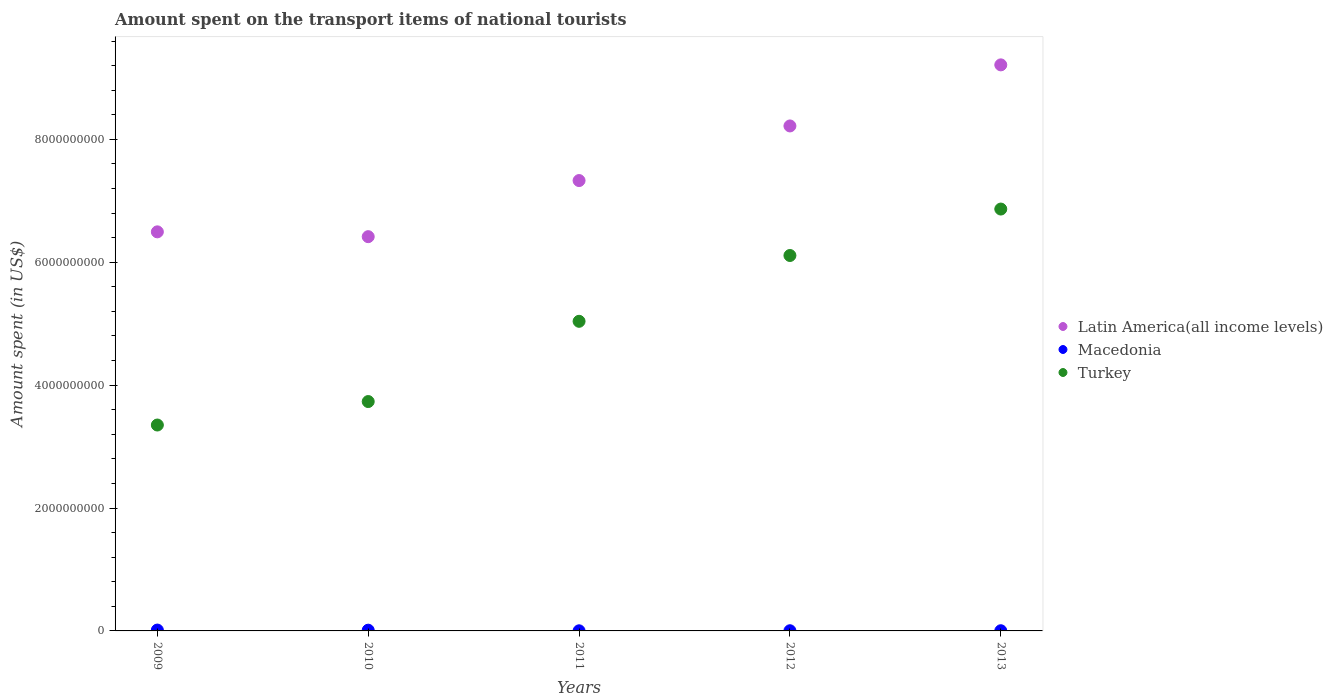What is the amount spent on the transport items of national tourists in Turkey in 2013?
Provide a short and direct response. 6.87e+09. Across all years, what is the maximum amount spent on the transport items of national tourists in Latin America(all income levels)?
Keep it short and to the point. 9.21e+09. Across all years, what is the minimum amount spent on the transport items of national tourists in Latin America(all income levels)?
Keep it short and to the point. 6.42e+09. In which year was the amount spent on the transport items of national tourists in Latin America(all income levels) maximum?
Offer a terse response. 2013. What is the total amount spent on the transport items of national tourists in Macedonia in the graph?
Your answer should be compact. 3.40e+07. What is the difference between the amount spent on the transport items of national tourists in Latin America(all income levels) in 2009 and that in 2011?
Your answer should be compact. -8.35e+08. What is the difference between the amount spent on the transport items of national tourists in Turkey in 2009 and the amount spent on the transport items of national tourists in Macedonia in 2010?
Provide a succinct answer. 3.34e+09. What is the average amount spent on the transport items of national tourists in Macedonia per year?
Provide a short and direct response. 6.80e+06. In the year 2013, what is the difference between the amount spent on the transport items of national tourists in Latin America(all income levels) and amount spent on the transport items of national tourists in Turkey?
Your answer should be very brief. 2.35e+09. What is the ratio of the amount spent on the transport items of national tourists in Turkey in 2012 to that in 2013?
Your answer should be compact. 0.89. What is the difference between the highest and the second highest amount spent on the transport items of national tourists in Macedonia?
Offer a very short reply. 2.00e+06. What is the difference between the highest and the lowest amount spent on the transport items of national tourists in Latin America(all income levels)?
Your answer should be compact. 2.80e+09. Is the amount spent on the transport items of national tourists in Turkey strictly less than the amount spent on the transport items of national tourists in Latin America(all income levels) over the years?
Make the answer very short. Yes. How many years are there in the graph?
Your response must be concise. 5. Does the graph contain any zero values?
Your answer should be very brief. No. Where does the legend appear in the graph?
Make the answer very short. Center right. How are the legend labels stacked?
Ensure brevity in your answer.  Vertical. What is the title of the graph?
Offer a very short reply. Amount spent on the transport items of national tourists. What is the label or title of the Y-axis?
Ensure brevity in your answer.  Amount spent (in US$). What is the Amount spent (in US$) in Latin America(all income levels) in 2009?
Your answer should be very brief. 6.49e+09. What is the Amount spent (in US$) in Macedonia in 2009?
Your response must be concise. 1.40e+07. What is the Amount spent (in US$) in Turkey in 2009?
Offer a very short reply. 3.35e+09. What is the Amount spent (in US$) of Latin America(all income levels) in 2010?
Keep it short and to the point. 6.42e+09. What is the Amount spent (in US$) of Macedonia in 2010?
Provide a short and direct response. 1.20e+07. What is the Amount spent (in US$) of Turkey in 2010?
Provide a succinct answer. 3.73e+09. What is the Amount spent (in US$) of Latin America(all income levels) in 2011?
Offer a very short reply. 7.33e+09. What is the Amount spent (in US$) in Turkey in 2011?
Your response must be concise. 5.04e+09. What is the Amount spent (in US$) of Latin America(all income levels) in 2012?
Offer a very short reply. 8.22e+09. What is the Amount spent (in US$) in Turkey in 2012?
Make the answer very short. 6.11e+09. What is the Amount spent (in US$) of Latin America(all income levels) in 2013?
Your answer should be compact. 9.21e+09. What is the Amount spent (in US$) of Turkey in 2013?
Offer a terse response. 6.87e+09. Across all years, what is the maximum Amount spent (in US$) of Latin America(all income levels)?
Offer a terse response. 9.21e+09. Across all years, what is the maximum Amount spent (in US$) of Macedonia?
Your answer should be compact. 1.40e+07. Across all years, what is the maximum Amount spent (in US$) of Turkey?
Keep it short and to the point. 6.87e+09. Across all years, what is the minimum Amount spent (in US$) in Latin America(all income levels)?
Make the answer very short. 6.42e+09. Across all years, what is the minimum Amount spent (in US$) of Macedonia?
Your response must be concise. 2.00e+06. Across all years, what is the minimum Amount spent (in US$) in Turkey?
Give a very brief answer. 3.35e+09. What is the total Amount spent (in US$) of Latin America(all income levels) in the graph?
Ensure brevity in your answer.  3.77e+1. What is the total Amount spent (in US$) of Macedonia in the graph?
Provide a succinct answer. 3.40e+07. What is the total Amount spent (in US$) in Turkey in the graph?
Offer a terse response. 2.51e+1. What is the difference between the Amount spent (in US$) of Latin America(all income levels) in 2009 and that in 2010?
Provide a short and direct response. 7.83e+07. What is the difference between the Amount spent (in US$) in Macedonia in 2009 and that in 2010?
Offer a terse response. 2.00e+06. What is the difference between the Amount spent (in US$) in Turkey in 2009 and that in 2010?
Provide a short and direct response. -3.82e+08. What is the difference between the Amount spent (in US$) in Latin America(all income levels) in 2009 and that in 2011?
Ensure brevity in your answer.  -8.35e+08. What is the difference between the Amount spent (in US$) of Turkey in 2009 and that in 2011?
Your response must be concise. -1.69e+09. What is the difference between the Amount spent (in US$) in Latin America(all income levels) in 2009 and that in 2012?
Provide a short and direct response. -1.72e+09. What is the difference between the Amount spent (in US$) in Macedonia in 2009 and that in 2012?
Provide a short and direct response. 1.10e+07. What is the difference between the Amount spent (in US$) in Turkey in 2009 and that in 2012?
Offer a very short reply. -2.76e+09. What is the difference between the Amount spent (in US$) of Latin America(all income levels) in 2009 and that in 2013?
Offer a terse response. -2.72e+09. What is the difference between the Amount spent (in US$) of Macedonia in 2009 and that in 2013?
Make the answer very short. 1.10e+07. What is the difference between the Amount spent (in US$) in Turkey in 2009 and that in 2013?
Give a very brief answer. -3.52e+09. What is the difference between the Amount spent (in US$) in Latin America(all income levels) in 2010 and that in 2011?
Your response must be concise. -9.13e+08. What is the difference between the Amount spent (in US$) of Macedonia in 2010 and that in 2011?
Keep it short and to the point. 1.00e+07. What is the difference between the Amount spent (in US$) of Turkey in 2010 and that in 2011?
Ensure brevity in your answer.  -1.31e+09. What is the difference between the Amount spent (in US$) of Latin America(all income levels) in 2010 and that in 2012?
Offer a terse response. -1.80e+09. What is the difference between the Amount spent (in US$) of Macedonia in 2010 and that in 2012?
Ensure brevity in your answer.  9.00e+06. What is the difference between the Amount spent (in US$) of Turkey in 2010 and that in 2012?
Make the answer very short. -2.38e+09. What is the difference between the Amount spent (in US$) in Latin America(all income levels) in 2010 and that in 2013?
Ensure brevity in your answer.  -2.80e+09. What is the difference between the Amount spent (in US$) of Macedonia in 2010 and that in 2013?
Ensure brevity in your answer.  9.00e+06. What is the difference between the Amount spent (in US$) of Turkey in 2010 and that in 2013?
Provide a short and direct response. -3.13e+09. What is the difference between the Amount spent (in US$) in Latin America(all income levels) in 2011 and that in 2012?
Keep it short and to the point. -8.89e+08. What is the difference between the Amount spent (in US$) of Turkey in 2011 and that in 2012?
Your response must be concise. -1.07e+09. What is the difference between the Amount spent (in US$) of Latin America(all income levels) in 2011 and that in 2013?
Your answer should be very brief. -1.88e+09. What is the difference between the Amount spent (in US$) of Macedonia in 2011 and that in 2013?
Your answer should be very brief. -1.00e+06. What is the difference between the Amount spent (in US$) of Turkey in 2011 and that in 2013?
Ensure brevity in your answer.  -1.83e+09. What is the difference between the Amount spent (in US$) in Latin America(all income levels) in 2012 and that in 2013?
Provide a succinct answer. -9.94e+08. What is the difference between the Amount spent (in US$) of Turkey in 2012 and that in 2013?
Your answer should be very brief. -7.56e+08. What is the difference between the Amount spent (in US$) of Latin America(all income levels) in 2009 and the Amount spent (in US$) of Macedonia in 2010?
Ensure brevity in your answer.  6.48e+09. What is the difference between the Amount spent (in US$) in Latin America(all income levels) in 2009 and the Amount spent (in US$) in Turkey in 2010?
Provide a short and direct response. 2.76e+09. What is the difference between the Amount spent (in US$) of Macedonia in 2009 and the Amount spent (in US$) of Turkey in 2010?
Your response must be concise. -3.72e+09. What is the difference between the Amount spent (in US$) of Latin America(all income levels) in 2009 and the Amount spent (in US$) of Macedonia in 2011?
Ensure brevity in your answer.  6.49e+09. What is the difference between the Amount spent (in US$) in Latin America(all income levels) in 2009 and the Amount spent (in US$) in Turkey in 2011?
Your response must be concise. 1.46e+09. What is the difference between the Amount spent (in US$) in Macedonia in 2009 and the Amount spent (in US$) in Turkey in 2011?
Your answer should be compact. -5.02e+09. What is the difference between the Amount spent (in US$) in Latin America(all income levels) in 2009 and the Amount spent (in US$) in Macedonia in 2012?
Your response must be concise. 6.49e+09. What is the difference between the Amount spent (in US$) in Latin America(all income levels) in 2009 and the Amount spent (in US$) in Turkey in 2012?
Provide a succinct answer. 3.85e+08. What is the difference between the Amount spent (in US$) of Macedonia in 2009 and the Amount spent (in US$) of Turkey in 2012?
Provide a succinct answer. -6.10e+09. What is the difference between the Amount spent (in US$) in Latin America(all income levels) in 2009 and the Amount spent (in US$) in Macedonia in 2013?
Your answer should be compact. 6.49e+09. What is the difference between the Amount spent (in US$) of Latin America(all income levels) in 2009 and the Amount spent (in US$) of Turkey in 2013?
Your response must be concise. -3.71e+08. What is the difference between the Amount spent (in US$) of Macedonia in 2009 and the Amount spent (in US$) of Turkey in 2013?
Your response must be concise. -6.85e+09. What is the difference between the Amount spent (in US$) in Latin America(all income levels) in 2010 and the Amount spent (in US$) in Macedonia in 2011?
Ensure brevity in your answer.  6.41e+09. What is the difference between the Amount spent (in US$) in Latin America(all income levels) in 2010 and the Amount spent (in US$) in Turkey in 2011?
Provide a succinct answer. 1.38e+09. What is the difference between the Amount spent (in US$) of Macedonia in 2010 and the Amount spent (in US$) of Turkey in 2011?
Give a very brief answer. -5.03e+09. What is the difference between the Amount spent (in US$) of Latin America(all income levels) in 2010 and the Amount spent (in US$) of Macedonia in 2012?
Make the answer very short. 6.41e+09. What is the difference between the Amount spent (in US$) in Latin America(all income levels) in 2010 and the Amount spent (in US$) in Turkey in 2012?
Keep it short and to the point. 3.07e+08. What is the difference between the Amount spent (in US$) of Macedonia in 2010 and the Amount spent (in US$) of Turkey in 2012?
Your response must be concise. -6.10e+09. What is the difference between the Amount spent (in US$) in Latin America(all income levels) in 2010 and the Amount spent (in US$) in Macedonia in 2013?
Give a very brief answer. 6.41e+09. What is the difference between the Amount spent (in US$) of Latin America(all income levels) in 2010 and the Amount spent (in US$) of Turkey in 2013?
Give a very brief answer. -4.49e+08. What is the difference between the Amount spent (in US$) of Macedonia in 2010 and the Amount spent (in US$) of Turkey in 2013?
Provide a succinct answer. -6.85e+09. What is the difference between the Amount spent (in US$) of Latin America(all income levels) in 2011 and the Amount spent (in US$) of Macedonia in 2012?
Offer a terse response. 7.33e+09. What is the difference between the Amount spent (in US$) of Latin America(all income levels) in 2011 and the Amount spent (in US$) of Turkey in 2012?
Give a very brief answer. 1.22e+09. What is the difference between the Amount spent (in US$) in Macedonia in 2011 and the Amount spent (in US$) in Turkey in 2012?
Your response must be concise. -6.11e+09. What is the difference between the Amount spent (in US$) in Latin America(all income levels) in 2011 and the Amount spent (in US$) in Macedonia in 2013?
Ensure brevity in your answer.  7.33e+09. What is the difference between the Amount spent (in US$) in Latin America(all income levels) in 2011 and the Amount spent (in US$) in Turkey in 2013?
Provide a short and direct response. 4.64e+08. What is the difference between the Amount spent (in US$) in Macedonia in 2011 and the Amount spent (in US$) in Turkey in 2013?
Offer a terse response. -6.86e+09. What is the difference between the Amount spent (in US$) of Latin America(all income levels) in 2012 and the Amount spent (in US$) of Macedonia in 2013?
Your answer should be compact. 8.22e+09. What is the difference between the Amount spent (in US$) in Latin America(all income levels) in 2012 and the Amount spent (in US$) in Turkey in 2013?
Provide a short and direct response. 1.35e+09. What is the difference between the Amount spent (in US$) of Macedonia in 2012 and the Amount spent (in US$) of Turkey in 2013?
Your answer should be very brief. -6.86e+09. What is the average Amount spent (in US$) in Latin America(all income levels) per year?
Your answer should be very brief. 7.53e+09. What is the average Amount spent (in US$) in Macedonia per year?
Make the answer very short. 6.80e+06. What is the average Amount spent (in US$) in Turkey per year?
Provide a succinct answer. 5.02e+09. In the year 2009, what is the difference between the Amount spent (in US$) in Latin America(all income levels) and Amount spent (in US$) in Macedonia?
Make the answer very short. 6.48e+09. In the year 2009, what is the difference between the Amount spent (in US$) in Latin America(all income levels) and Amount spent (in US$) in Turkey?
Keep it short and to the point. 3.14e+09. In the year 2009, what is the difference between the Amount spent (in US$) of Macedonia and Amount spent (in US$) of Turkey?
Ensure brevity in your answer.  -3.34e+09. In the year 2010, what is the difference between the Amount spent (in US$) of Latin America(all income levels) and Amount spent (in US$) of Macedonia?
Your answer should be compact. 6.40e+09. In the year 2010, what is the difference between the Amount spent (in US$) in Latin America(all income levels) and Amount spent (in US$) in Turkey?
Offer a very short reply. 2.68e+09. In the year 2010, what is the difference between the Amount spent (in US$) in Macedonia and Amount spent (in US$) in Turkey?
Make the answer very short. -3.72e+09. In the year 2011, what is the difference between the Amount spent (in US$) in Latin America(all income levels) and Amount spent (in US$) in Macedonia?
Your response must be concise. 7.33e+09. In the year 2011, what is the difference between the Amount spent (in US$) in Latin America(all income levels) and Amount spent (in US$) in Turkey?
Offer a very short reply. 2.29e+09. In the year 2011, what is the difference between the Amount spent (in US$) in Macedonia and Amount spent (in US$) in Turkey?
Your response must be concise. -5.04e+09. In the year 2012, what is the difference between the Amount spent (in US$) in Latin America(all income levels) and Amount spent (in US$) in Macedonia?
Provide a succinct answer. 8.22e+09. In the year 2012, what is the difference between the Amount spent (in US$) in Latin America(all income levels) and Amount spent (in US$) in Turkey?
Your answer should be very brief. 2.11e+09. In the year 2012, what is the difference between the Amount spent (in US$) in Macedonia and Amount spent (in US$) in Turkey?
Your answer should be very brief. -6.11e+09. In the year 2013, what is the difference between the Amount spent (in US$) of Latin America(all income levels) and Amount spent (in US$) of Macedonia?
Ensure brevity in your answer.  9.21e+09. In the year 2013, what is the difference between the Amount spent (in US$) in Latin America(all income levels) and Amount spent (in US$) in Turkey?
Offer a very short reply. 2.35e+09. In the year 2013, what is the difference between the Amount spent (in US$) in Macedonia and Amount spent (in US$) in Turkey?
Keep it short and to the point. -6.86e+09. What is the ratio of the Amount spent (in US$) in Latin America(all income levels) in 2009 to that in 2010?
Your answer should be compact. 1.01. What is the ratio of the Amount spent (in US$) of Turkey in 2009 to that in 2010?
Keep it short and to the point. 0.9. What is the ratio of the Amount spent (in US$) in Latin America(all income levels) in 2009 to that in 2011?
Keep it short and to the point. 0.89. What is the ratio of the Amount spent (in US$) of Turkey in 2009 to that in 2011?
Make the answer very short. 0.67. What is the ratio of the Amount spent (in US$) in Latin America(all income levels) in 2009 to that in 2012?
Offer a terse response. 0.79. What is the ratio of the Amount spent (in US$) of Macedonia in 2009 to that in 2012?
Your answer should be compact. 4.67. What is the ratio of the Amount spent (in US$) in Turkey in 2009 to that in 2012?
Your response must be concise. 0.55. What is the ratio of the Amount spent (in US$) in Latin America(all income levels) in 2009 to that in 2013?
Give a very brief answer. 0.7. What is the ratio of the Amount spent (in US$) in Macedonia in 2009 to that in 2013?
Your response must be concise. 4.67. What is the ratio of the Amount spent (in US$) of Turkey in 2009 to that in 2013?
Offer a terse response. 0.49. What is the ratio of the Amount spent (in US$) in Latin America(all income levels) in 2010 to that in 2011?
Give a very brief answer. 0.88. What is the ratio of the Amount spent (in US$) in Macedonia in 2010 to that in 2011?
Offer a terse response. 6. What is the ratio of the Amount spent (in US$) in Turkey in 2010 to that in 2011?
Make the answer very short. 0.74. What is the ratio of the Amount spent (in US$) in Latin America(all income levels) in 2010 to that in 2012?
Ensure brevity in your answer.  0.78. What is the ratio of the Amount spent (in US$) in Turkey in 2010 to that in 2012?
Your answer should be very brief. 0.61. What is the ratio of the Amount spent (in US$) in Latin America(all income levels) in 2010 to that in 2013?
Your response must be concise. 0.7. What is the ratio of the Amount spent (in US$) of Turkey in 2010 to that in 2013?
Keep it short and to the point. 0.54. What is the ratio of the Amount spent (in US$) in Latin America(all income levels) in 2011 to that in 2012?
Your answer should be very brief. 0.89. What is the ratio of the Amount spent (in US$) in Macedonia in 2011 to that in 2012?
Give a very brief answer. 0.67. What is the ratio of the Amount spent (in US$) of Turkey in 2011 to that in 2012?
Keep it short and to the point. 0.82. What is the ratio of the Amount spent (in US$) in Latin America(all income levels) in 2011 to that in 2013?
Provide a short and direct response. 0.8. What is the ratio of the Amount spent (in US$) of Turkey in 2011 to that in 2013?
Offer a terse response. 0.73. What is the ratio of the Amount spent (in US$) of Latin America(all income levels) in 2012 to that in 2013?
Make the answer very short. 0.89. What is the ratio of the Amount spent (in US$) in Turkey in 2012 to that in 2013?
Provide a succinct answer. 0.89. What is the difference between the highest and the second highest Amount spent (in US$) in Latin America(all income levels)?
Give a very brief answer. 9.94e+08. What is the difference between the highest and the second highest Amount spent (in US$) in Turkey?
Your response must be concise. 7.56e+08. What is the difference between the highest and the lowest Amount spent (in US$) in Latin America(all income levels)?
Make the answer very short. 2.80e+09. What is the difference between the highest and the lowest Amount spent (in US$) of Macedonia?
Provide a succinct answer. 1.20e+07. What is the difference between the highest and the lowest Amount spent (in US$) of Turkey?
Provide a short and direct response. 3.52e+09. 